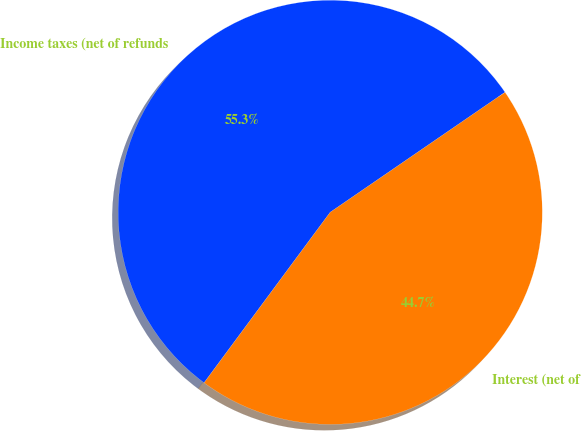Convert chart. <chart><loc_0><loc_0><loc_500><loc_500><pie_chart><fcel>Income taxes (net of refunds<fcel>Interest (net of<nl><fcel>55.29%<fcel>44.71%<nl></chart> 